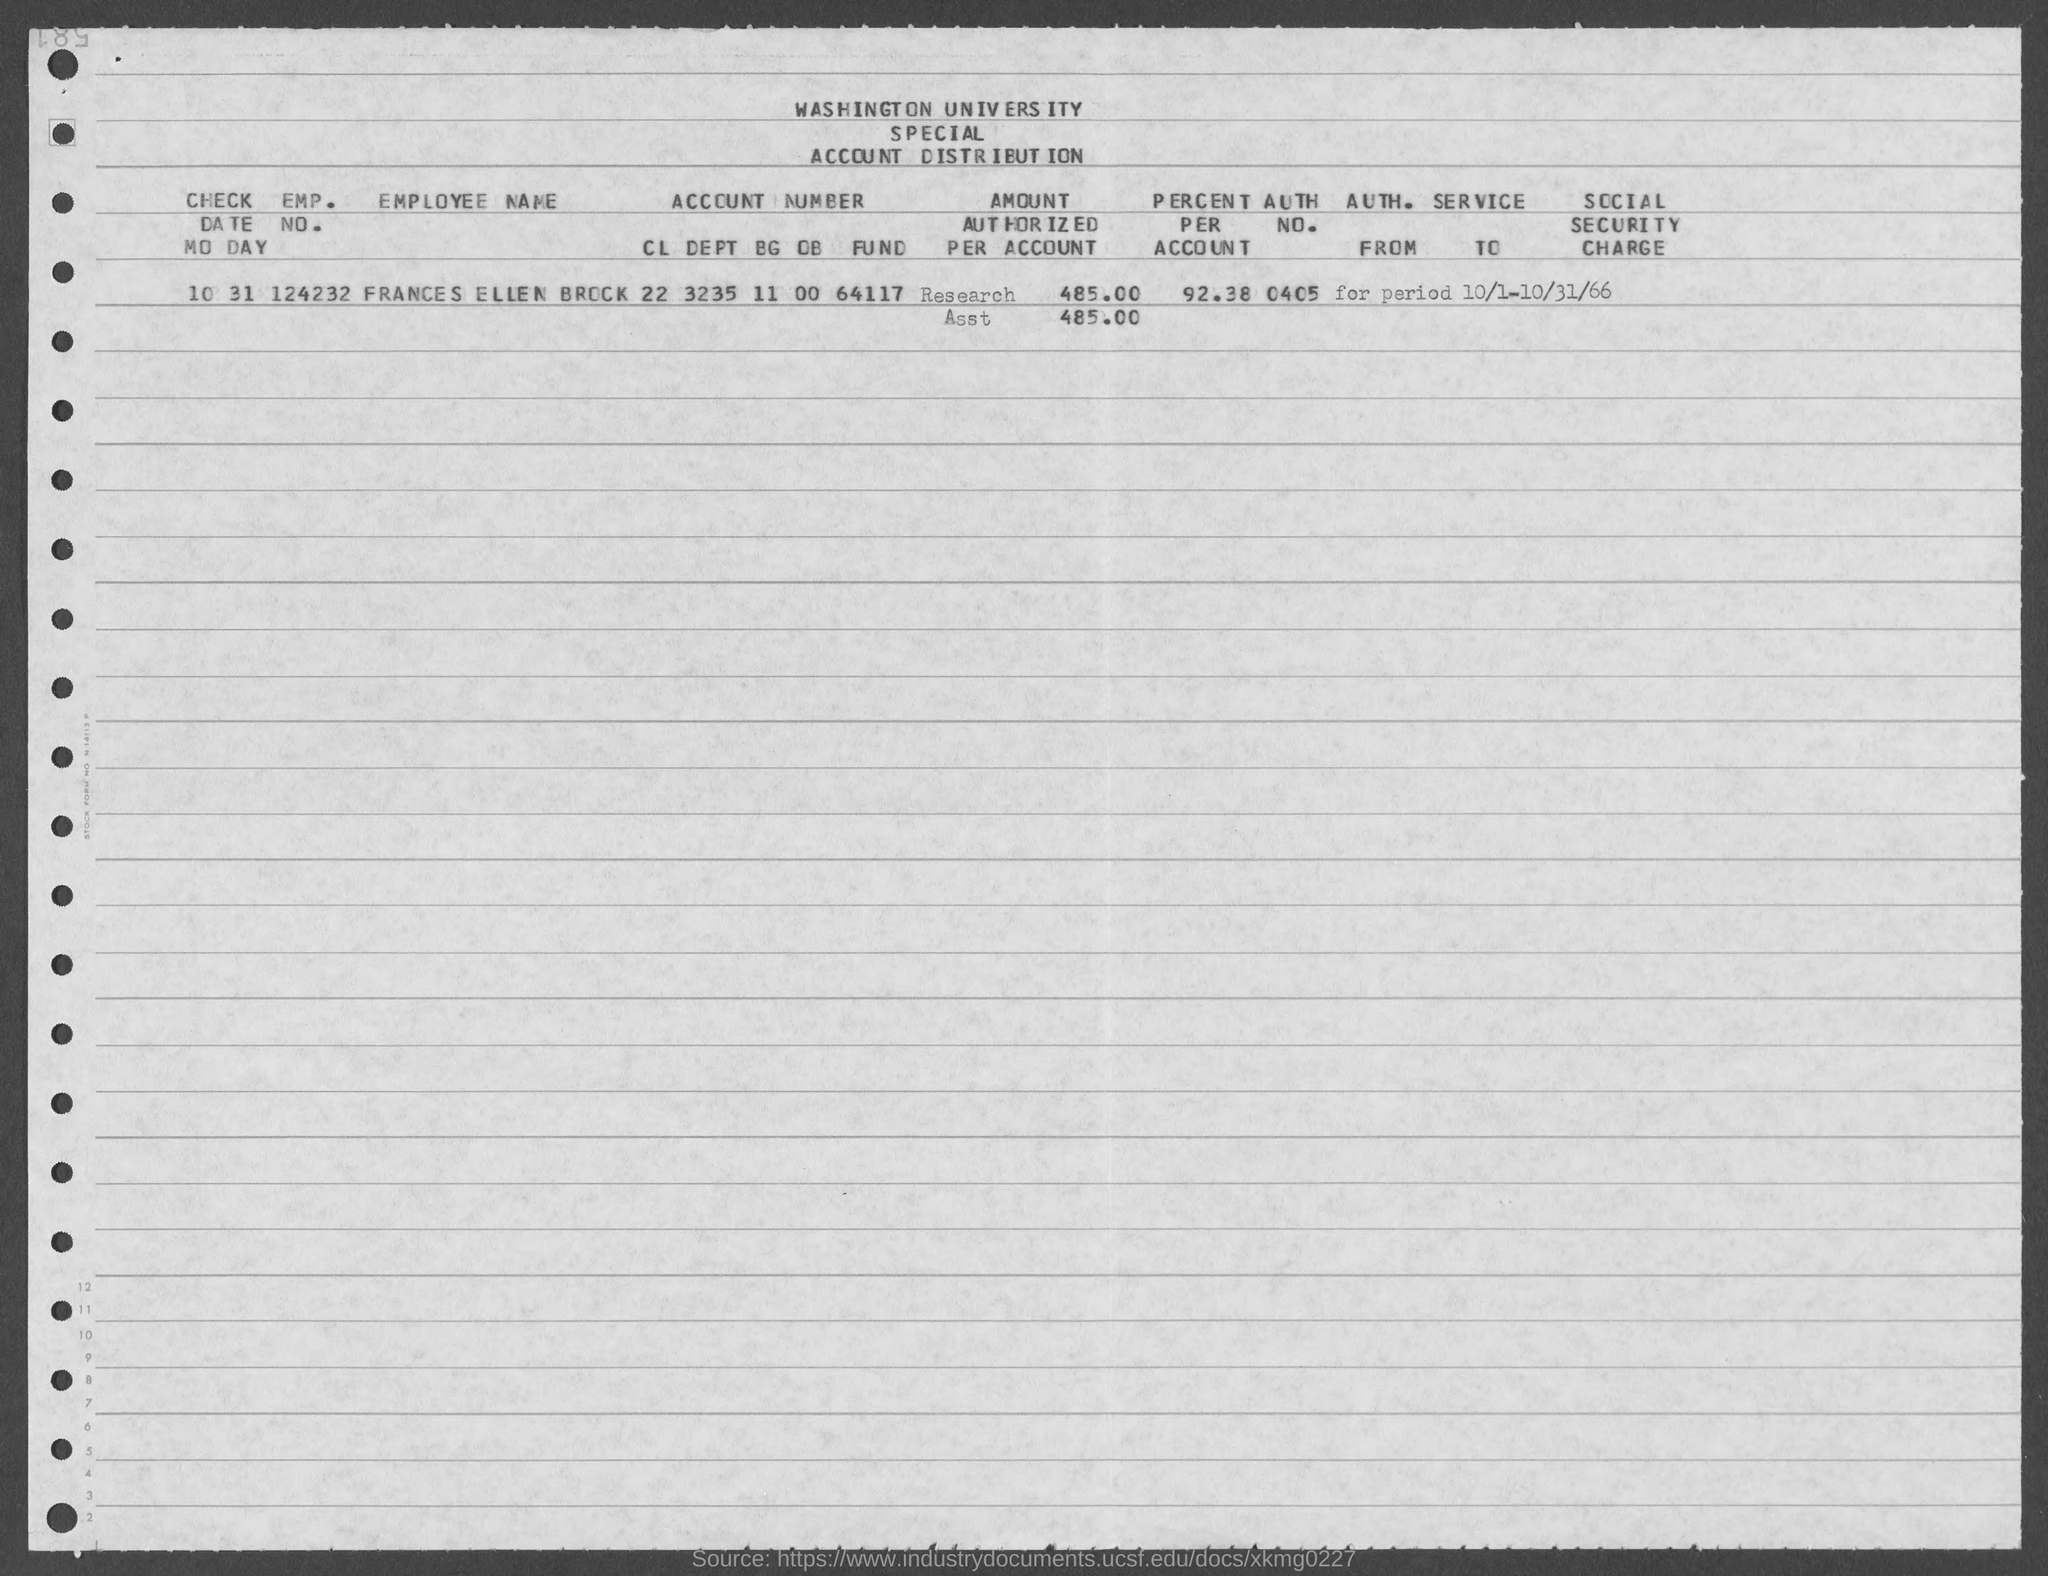Specify some key components in this picture. The employment number of Frances Ellen Brock is 124232. The identity number of Frances Ellen Brock is 0405... Frances Ellen Brock's percentage for the given amount is 92.38%. 